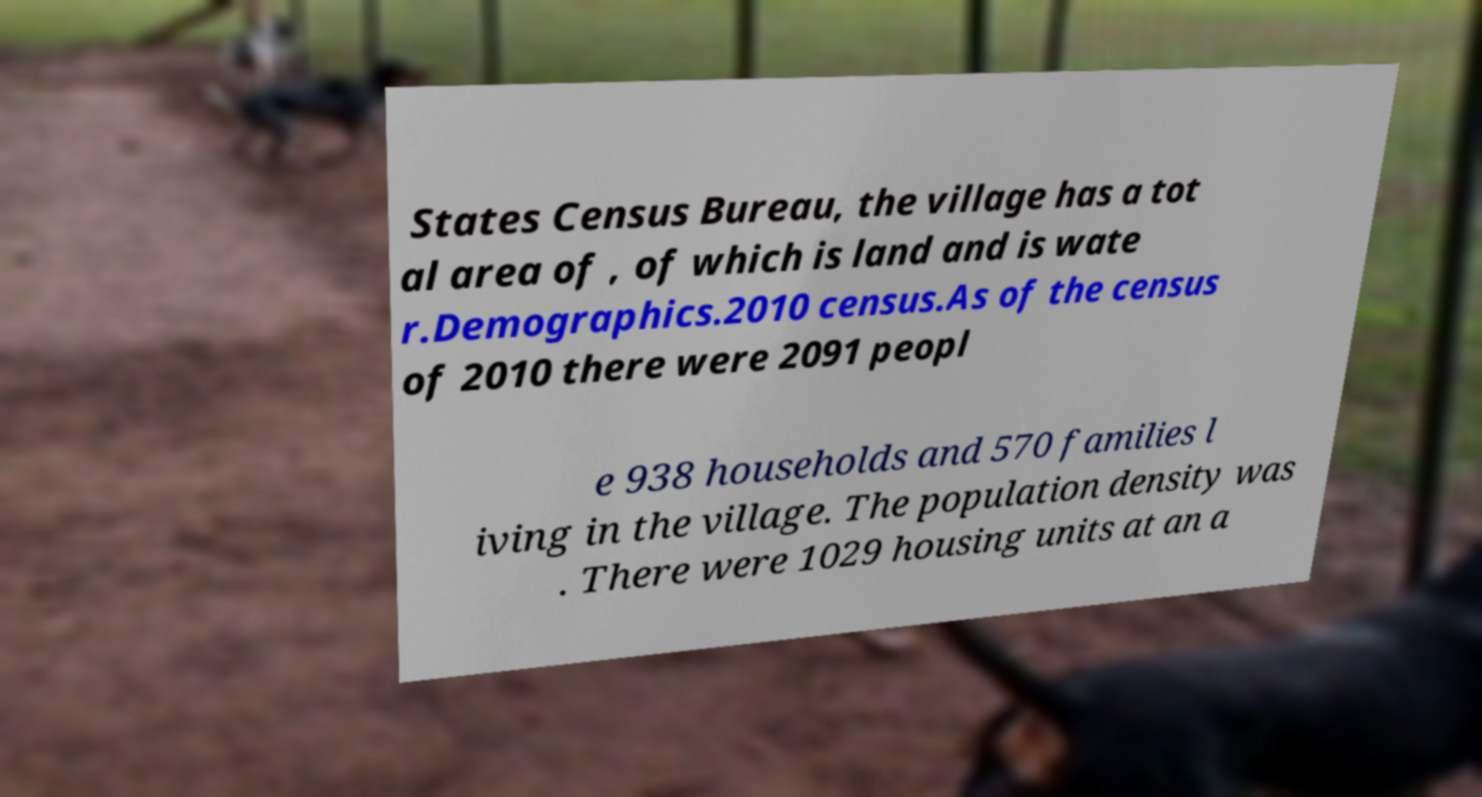Could you extract and type out the text from this image? States Census Bureau, the village has a tot al area of , of which is land and is wate r.Demographics.2010 census.As of the census of 2010 there were 2091 peopl e 938 households and 570 families l iving in the village. The population density was . There were 1029 housing units at an a 